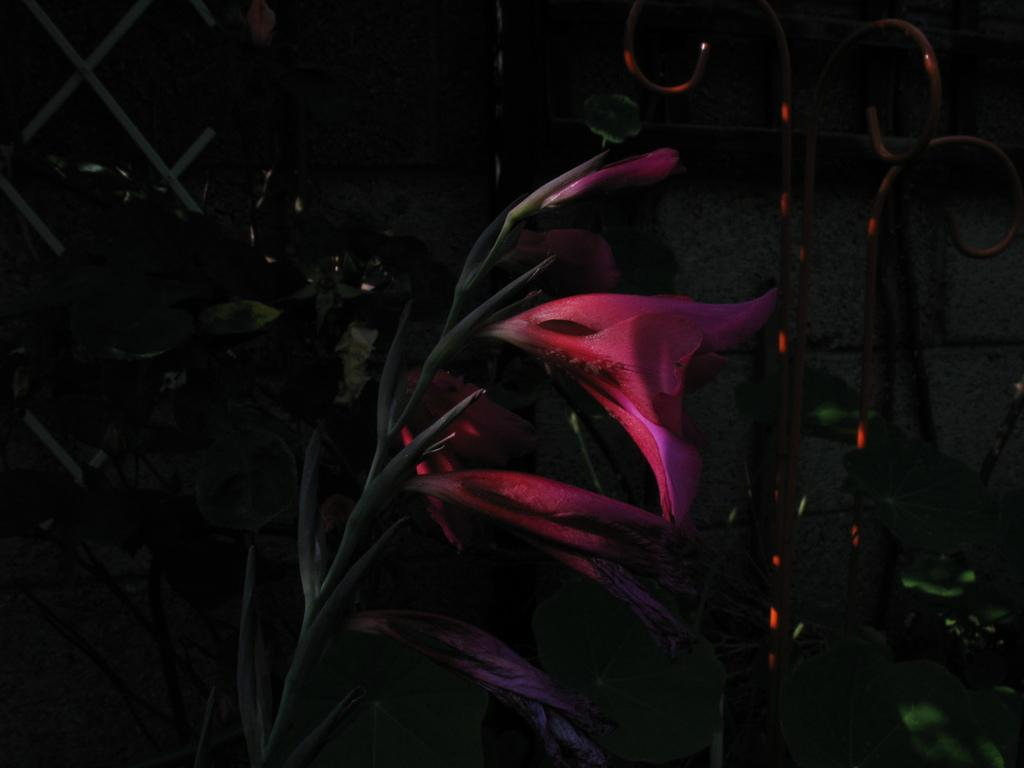What color are the flowers in the image? The flowers in the image are pink. What color are the leaves in the image? The leaves in the image are green. What type of structure can be seen in the image? There is a wall in the image. What type of barrier is present in the image? There is an iron railing in the image. How many cabbages can be seen in the image? There are no cabbages present in the image. What type of animal is standing next to the wall in the image? There is no animal, such as a giraffe, present in the image. 